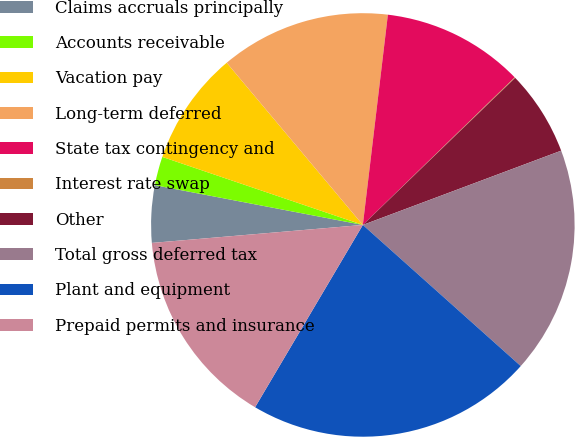<chart> <loc_0><loc_0><loc_500><loc_500><pie_chart><fcel>Claims accruals principally<fcel>Accounts receivable<fcel>Vacation pay<fcel>Long-term deferred<fcel>State tax contingency and<fcel>Interest rate swap<fcel>Other<fcel>Total gross deferred tax<fcel>Plant and equipment<fcel>Prepaid permits and insurance<nl><fcel>4.36%<fcel>2.2%<fcel>8.68%<fcel>13.0%<fcel>10.84%<fcel>0.05%<fcel>6.52%<fcel>17.31%<fcel>21.89%<fcel>15.15%<nl></chart> 